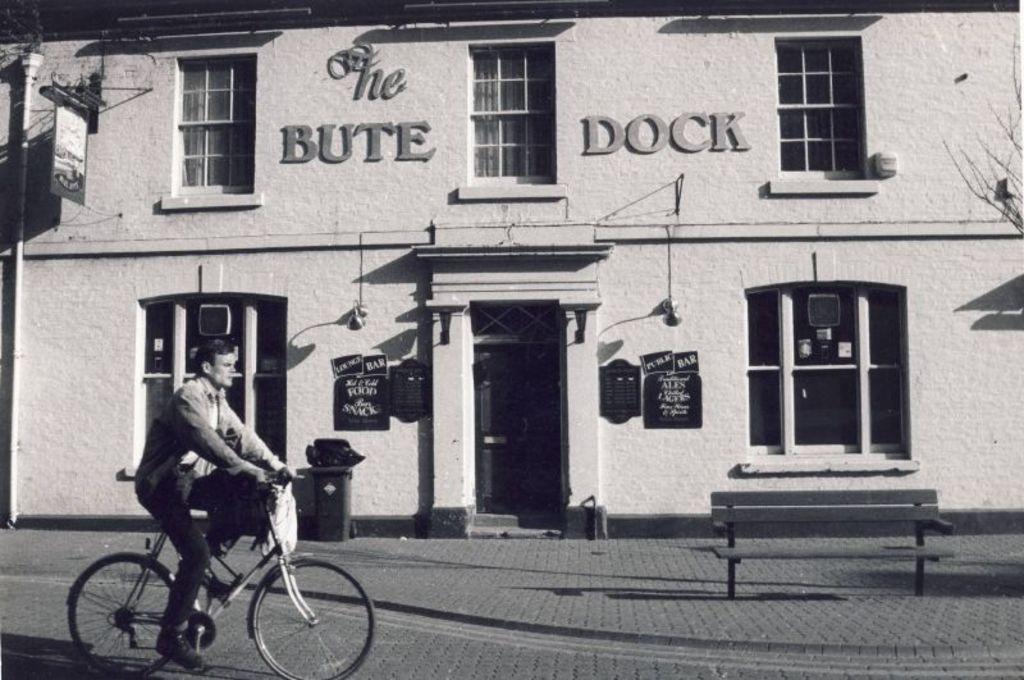Could you give a brief overview of what you see in this image? This image is clicked outside the house. There is a man riding bicycle, he is wearing a jacket. In the background there is a building, which is having windows, doors and boards. And it is written has Boot Dock on the building. 